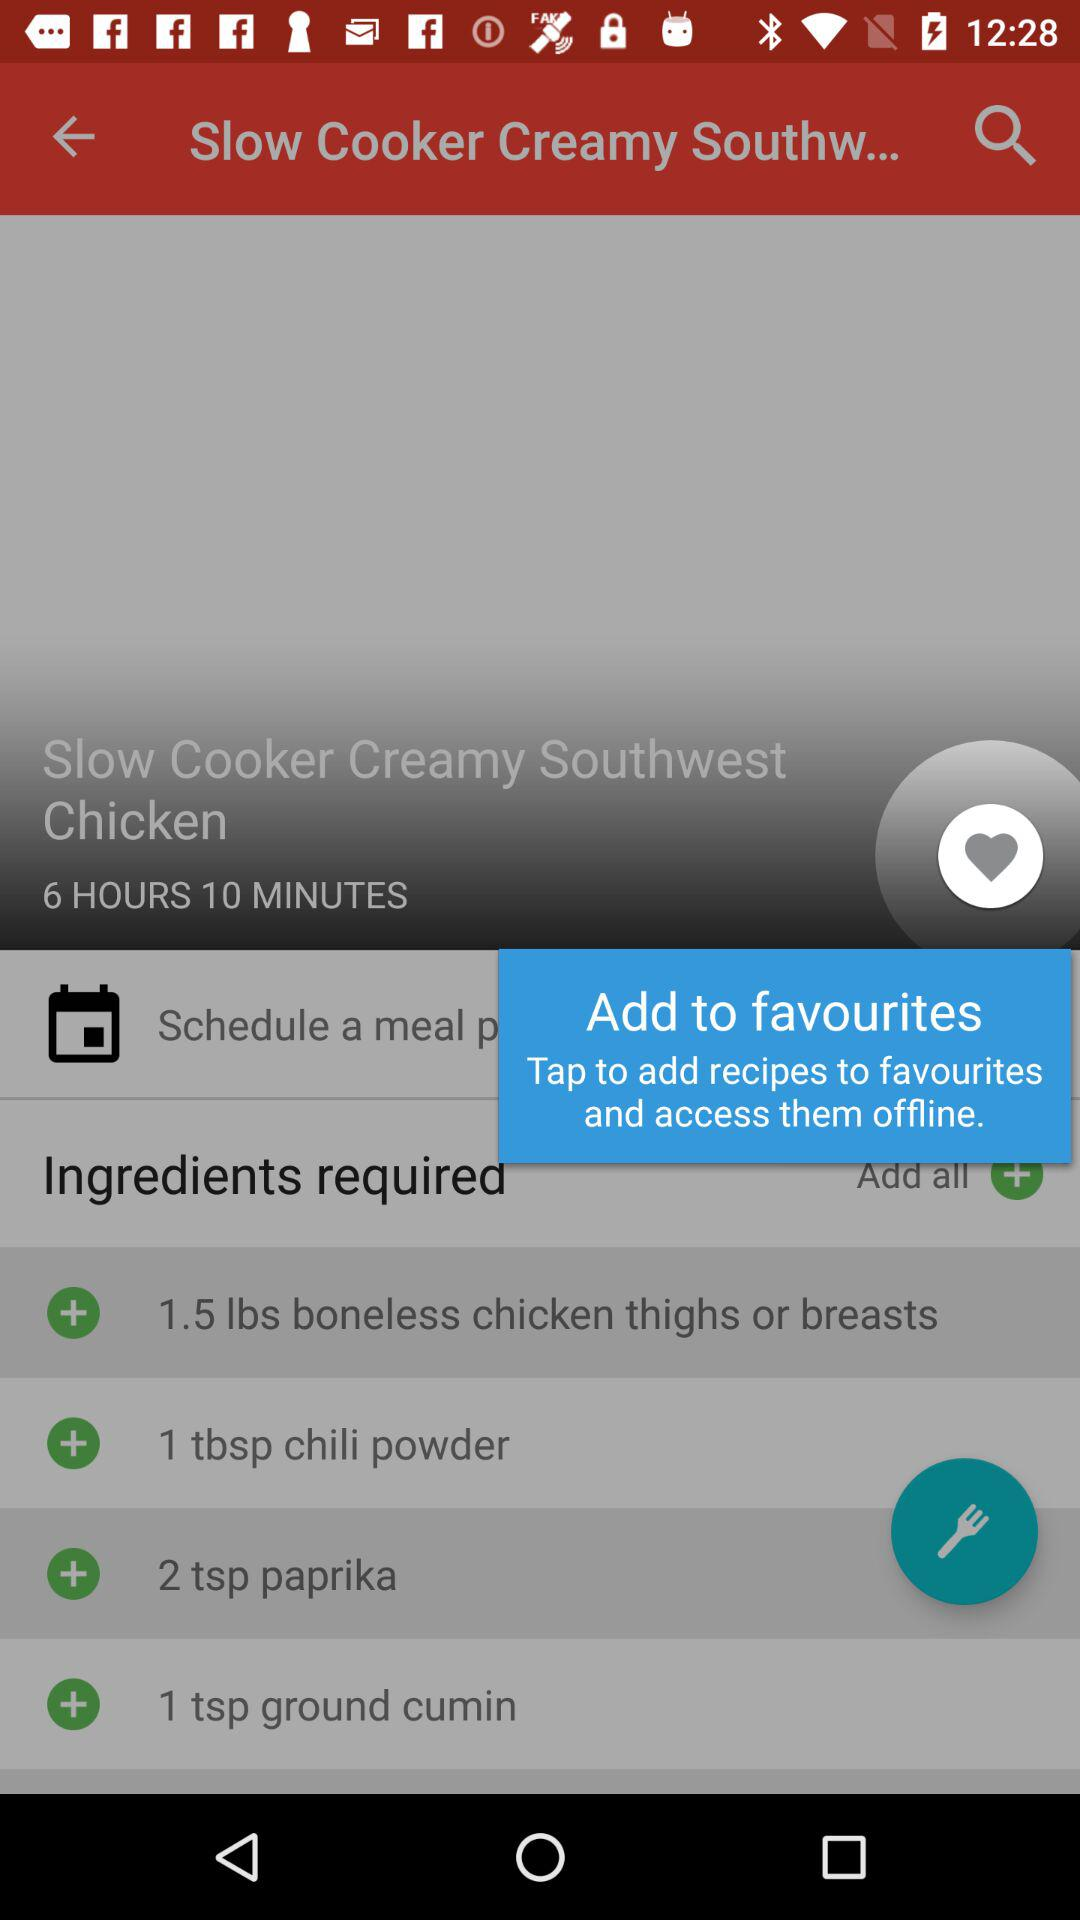How many ingredients are required for this recipe?
Answer the question using a single word or phrase. 4 